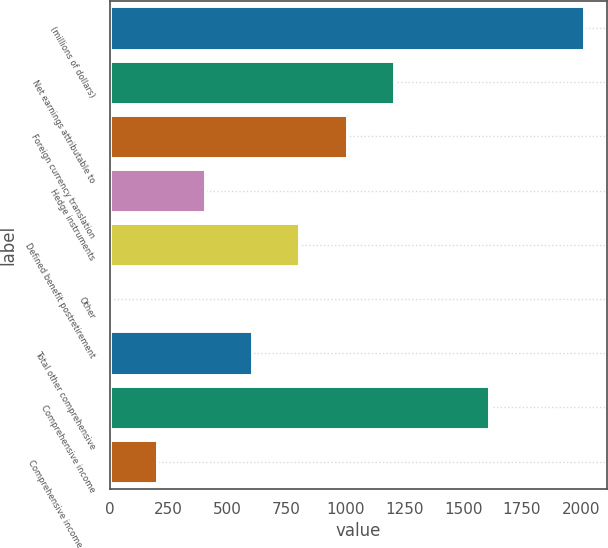Convert chart to OTSL. <chart><loc_0><loc_0><loc_500><loc_500><bar_chart><fcel>(millions of dollars)<fcel>Net earnings attributable to<fcel>Foreign currency translation<fcel>Hedge instruments<fcel>Defined benefit postretirement<fcel>Other<fcel>Total other comprehensive<fcel>Comprehensive income<fcel>Comprehensive income (loss)<nl><fcel>2012<fcel>1207.28<fcel>1006.1<fcel>402.56<fcel>804.92<fcel>0.2<fcel>603.74<fcel>1609.64<fcel>201.38<nl></chart> 